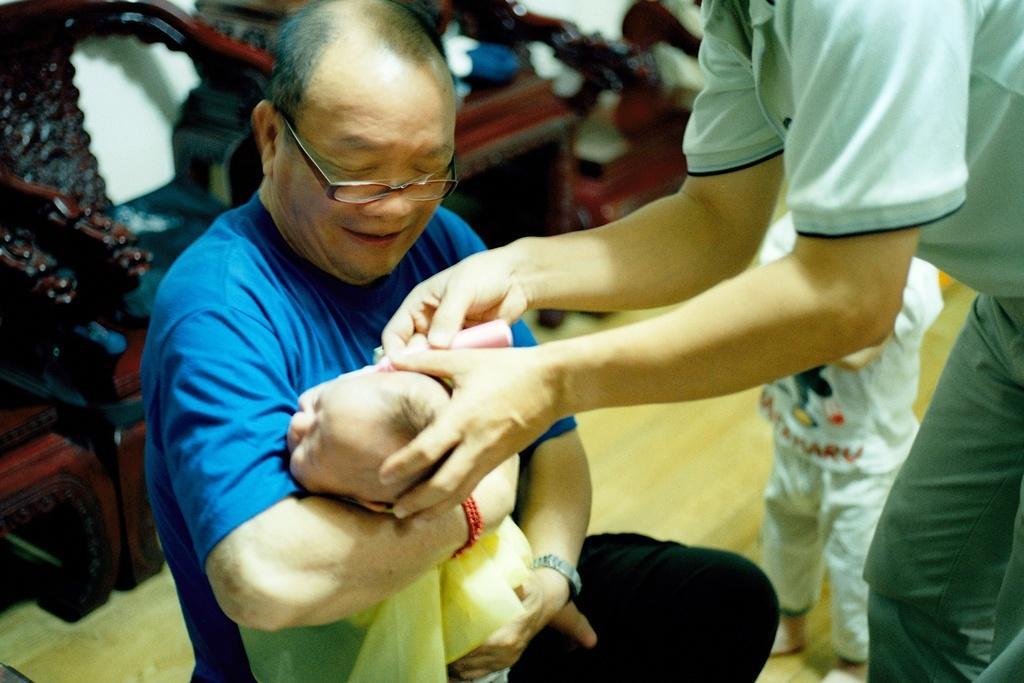Please provide a concise description of this image. In this image we can see a few people, among them one person is carrying a baby and the other person is holding an object, in the background we can see some objects and the wall. 